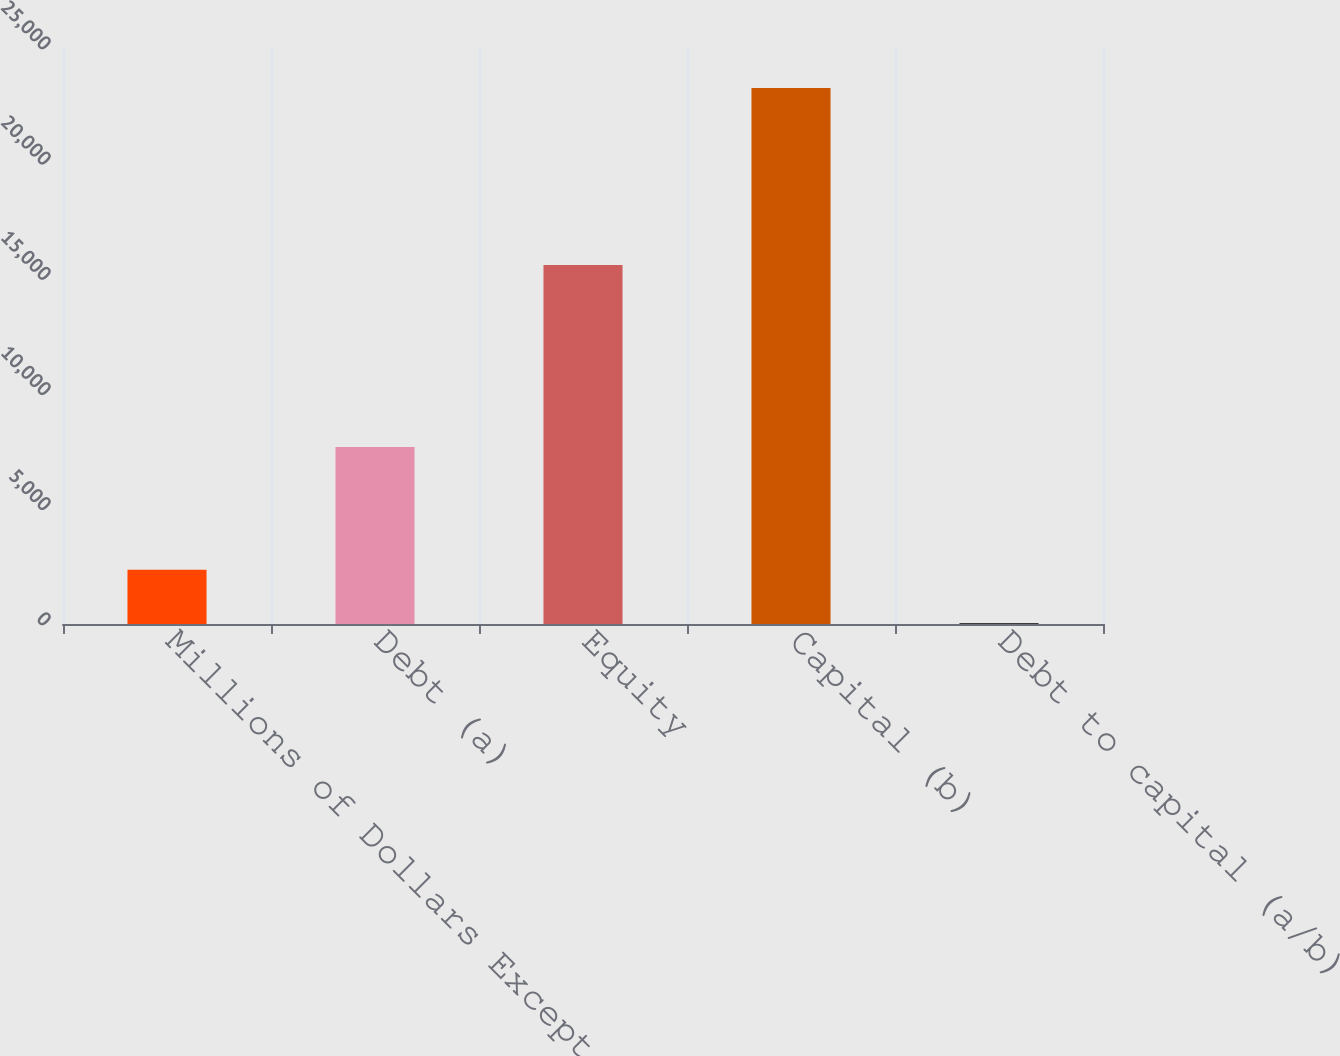Convert chart. <chart><loc_0><loc_0><loc_500><loc_500><bar_chart><fcel>Millions of Dollars Except<fcel>Debt (a)<fcel>Equity<fcel>Capital (b)<fcel>Debt to capital (a/b)<nl><fcel>2356.4<fcel>7682<fcel>15585<fcel>23267<fcel>33<nl></chart> 